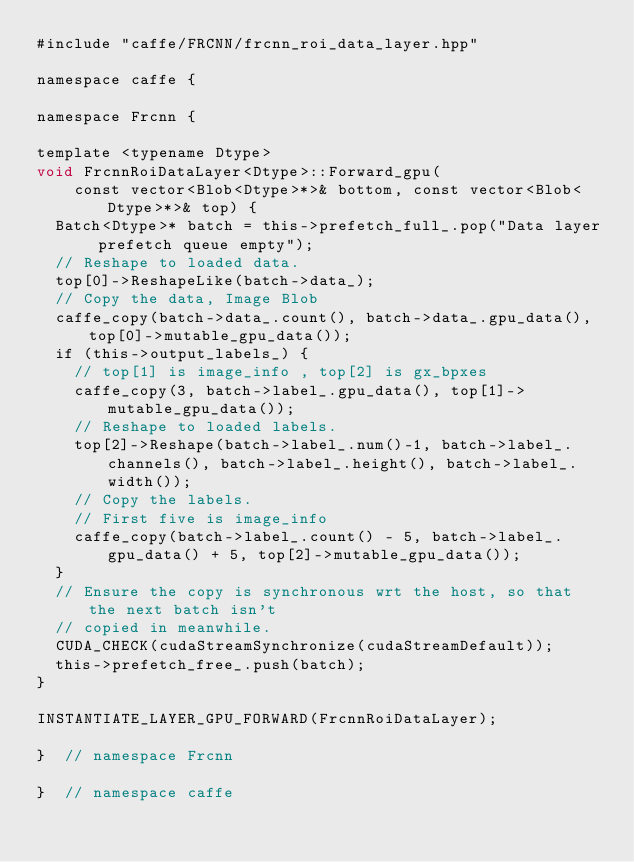<code> <loc_0><loc_0><loc_500><loc_500><_Cuda_>#include "caffe/FRCNN/frcnn_roi_data_layer.hpp"

namespace caffe {

namespace Frcnn {

template <typename Dtype>
void FrcnnRoiDataLayer<Dtype>::Forward_gpu(
    const vector<Blob<Dtype>*>& bottom, const vector<Blob<Dtype>*>& top) {
  Batch<Dtype>* batch = this->prefetch_full_.pop("Data layer prefetch queue empty");
  // Reshape to loaded data.
  top[0]->ReshapeLike(batch->data_);
  // Copy the data, Image Blob
  caffe_copy(batch->data_.count(), batch->data_.gpu_data(), top[0]->mutable_gpu_data());
  if (this->output_labels_) {
    // top[1] is image_info , top[2] is gx_bpxes
    caffe_copy(3, batch->label_.gpu_data(), top[1]->mutable_gpu_data());
    // Reshape to loaded labels.
    top[2]->Reshape(batch->label_.num()-1, batch->label_.channels(), batch->label_.height(), batch->label_.width());
    // Copy the labels.
    // First five is image_info
    caffe_copy(batch->label_.count() - 5, batch->label_.gpu_data() + 5, top[2]->mutable_gpu_data());
  }
  // Ensure the copy is synchronous wrt the host, so that the next batch isn't
  // copied in meanwhile.
  CUDA_CHECK(cudaStreamSynchronize(cudaStreamDefault));
  this->prefetch_free_.push(batch);
}

INSTANTIATE_LAYER_GPU_FORWARD(FrcnnRoiDataLayer);

}  // namespace Frcnn

}  // namespace caffe
</code> 